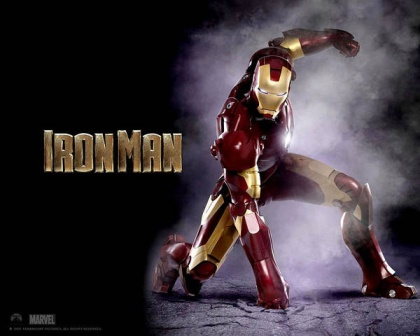How would the world look to someone inside Iron Man's suit, particularly in a high-stakes battle scenario? Inside Iron Man's suit during a high-stakes battle, the world would be a swirl of superimposed digital readouts and precise targeting indicators. The Heads-Up Display (HUD) offers a 360-degree view, highlighting allies and enemies with vibrant markers. Critical information is relayed in real-time, including enemy movements, structural weaknesses, and suggested countermeasures. Advanced sensors detect and predict incoming threats, superimposing alerts and evasive paths onto the visual field. The cacophony of battle outside would be dampened, with crucial sounds filtered and enhanced for situational awareness. Rapid data analysis aids decision-making, transforming chaos into a controlled environment where Tony orchestrates his moves with precision and ease. 